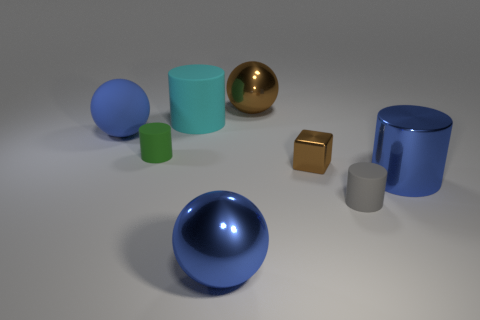Add 1 small cyan cylinders. How many objects exist? 9 Subtract all cubes. How many objects are left? 7 Subtract 0 yellow cylinders. How many objects are left? 8 Subtract all small purple things. Subtract all large blue objects. How many objects are left? 5 Add 5 big cylinders. How many big cylinders are left? 7 Add 3 large shiny objects. How many large shiny objects exist? 6 